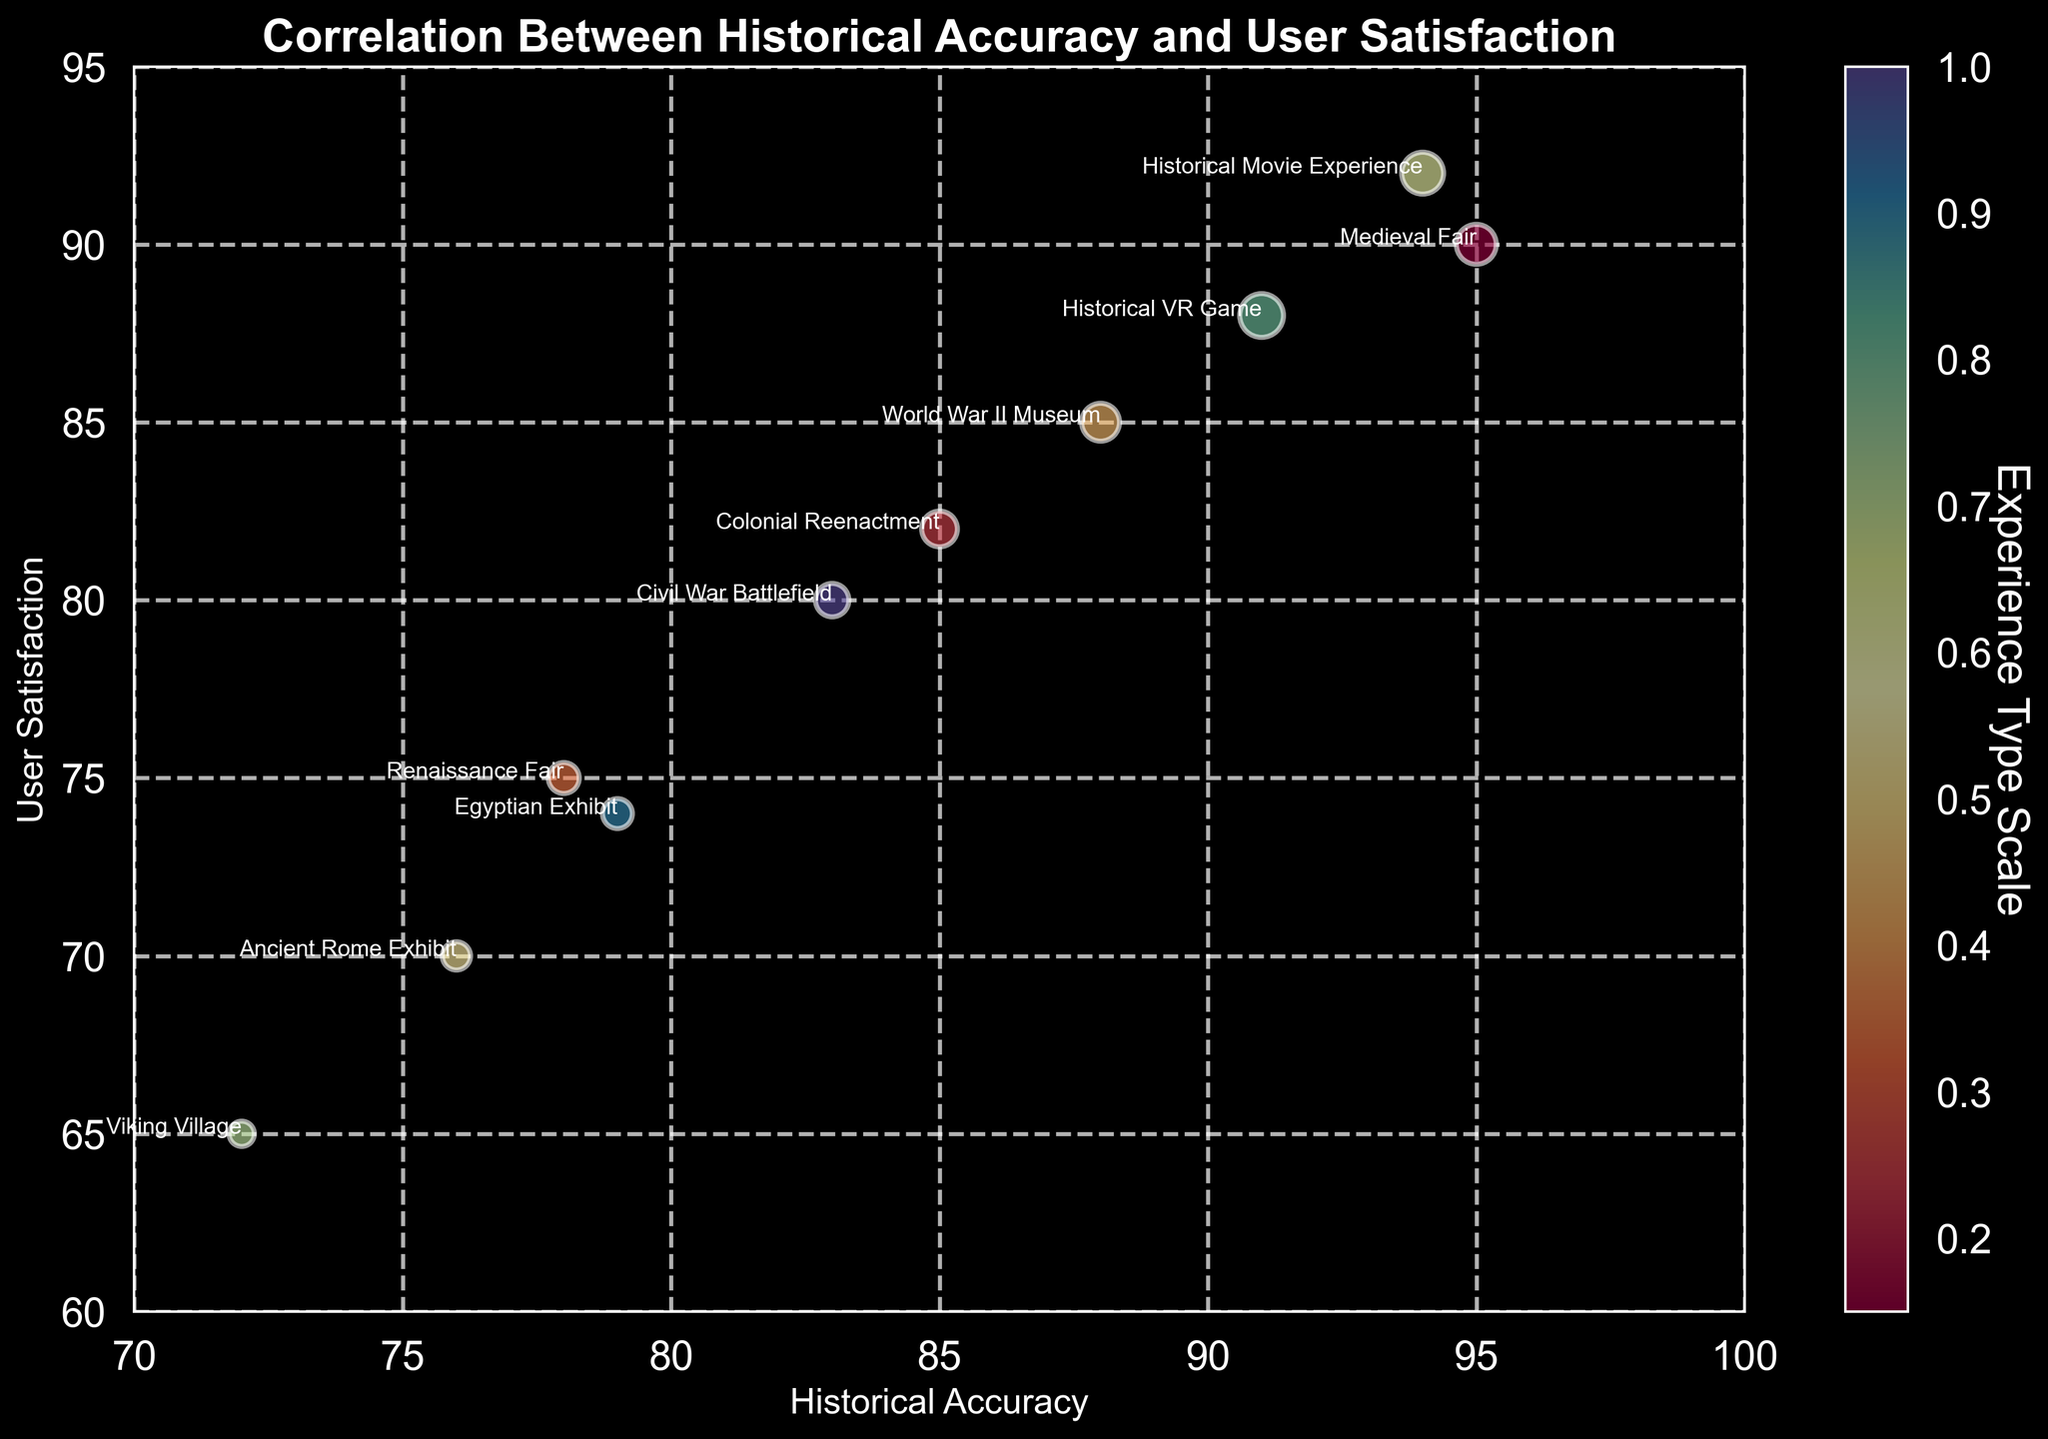Which experience type has the highest user satisfaction? By examining the y-axis values representing user satisfaction, look for the data point that reaches the highest along the y-axis. The highest user satisfaction value is at 92, which corresponds to the Historical Movie Experience.
Answer: Historical Movie Experience Which experience has the lowest historical accuracy, and what is its user satisfaction? By locating the data point lowest on the x-axis for historical accuracy, then looking at its corresponding y-axis value for user satisfaction. The lowest historical accuracy is 72 associated with the Viking Village, and its user satisfaction is 65.
Answer: Viking Village, 65 Compare the user satisfaction between the World War II Museum and the Colonial Reenactment. Which one is higher? By locating both the World War II Museum and Colonial Reenactment data points and examining their y-axis values for user satisfaction: World War II Museum at 85 and Colonial Reenactment at 82. The World War II Museum has the higher user satisfaction.
Answer: World War II Museum Which experiences have a user satisfaction greater than 80 but less than 90? By examining the y-axis and identifying data points that fall in the range of 80 to 90. The experiences falling within this range are Colonial Reenactment (82), World War II Museum (85), and Historical VR Game (88).
Answer: Colonial Reenactment, World War II Museum, Historical VR Game Is there a strong correlation between historical accuracy and user satisfaction? By observing the overall trend in the scatter plot. The correlation appears positive, where higher historical accuracy tends to align with higher user satisfaction values, indicating a strong correlation.
Answer: Yes What is the bubble size representing for the Medieval Fair, and how does it compare to other experiences? By looking at the size of the bubble representing the Medieval Fair. The size is 50, and compared to others, it's smaller than Historical VR Game and Historical Movie Experience but larger than Viking Village and Ancient Rome Exhibit.
Answer: 50 Considering the Renaissance Fair, what are its historical accuracy and user satisfaction values, and how do they compare to the Civil War Battlefield? Locate the Renaissance Fair data point and compare both historical accuracy (78) and user satisfaction (75) to the Civil War Battlefield (historical accuracy 83, user satisfaction 80). The Civil War Battlefield has higher values in both metrics.
Answer: Renaissance Fair: 78, 75; Civil War Battlefield: 83, 80 Which experience has the largest bubble size, and what does it signify in terms of the Experience Type Scale? The largest bubble size corresponds to the Historical VR Game valued at 60, signifying it is scaled largest regarding the Experience Type Scale shown in the color bar.
Answer: Historical VR Game How does the Egyptian Exhibit compare to the Ancient Rome Exhibit in terms of both historical accuracy and user satisfaction? By locating both data points, compare their x and y-axis values. Egyptian Exhibit (79, 74) compared to Ancient Rome Exhibit (76, 70) shows that Egyptian Exhibit has higher values in both historical accuracy and user satisfaction.
Answer: Egyptian Exhibit: 79, 74; Ancient Rome Exhibit: 76, 70 